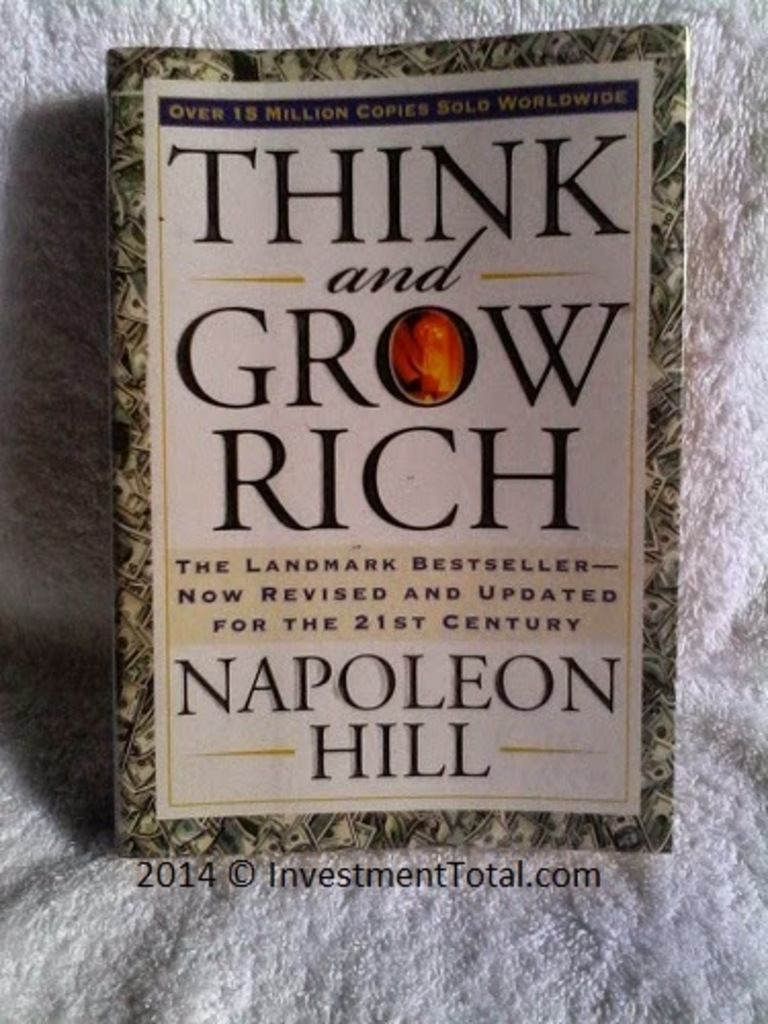What significance does the emblem with the word 'Rich' on the cover of 'Think and Grow Rich' hold? The emblem featuring the word 'Rich' on the cover serves as a focal point that draws the viewer's attention to the central theme of the book—wealth creation. The design choice to highlight this word with a distinctive red color amidst the green and gold palette symbolizes prosperity and success, core concepts discussed in Napoleon Hill's teachings. This emblem not only enhances the aesthetic appeal of the cover but also encapsulates the essence of the book, making it instantly recognizable and impactful. 